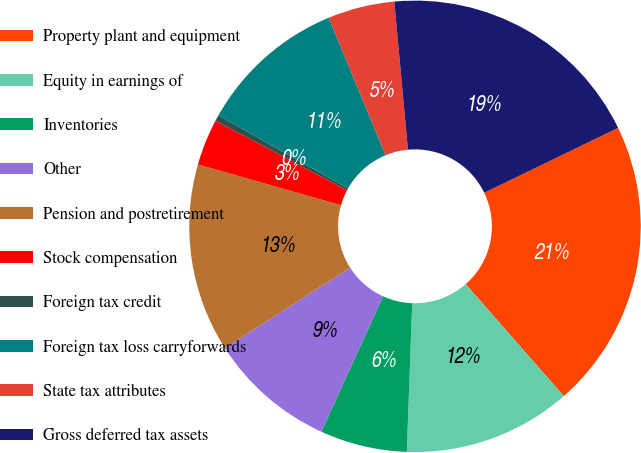<chart> <loc_0><loc_0><loc_500><loc_500><pie_chart><fcel>Property plant and equipment<fcel>Equity in earnings of<fcel>Inventories<fcel>Other<fcel>Pension and postretirement<fcel>Stock compensation<fcel>Foreign tax credit<fcel>Foreign tax loss carryforwards<fcel>State tax attributes<fcel>Gross deferred tax assets<nl><fcel>20.73%<fcel>12.03%<fcel>6.23%<fcel>9.13%<fcel>13.48%<fcel>3.33%<fcel>0.43%<fcel>10.58%<fcel>4.78%<fcel>19.28%<nl></chart> 